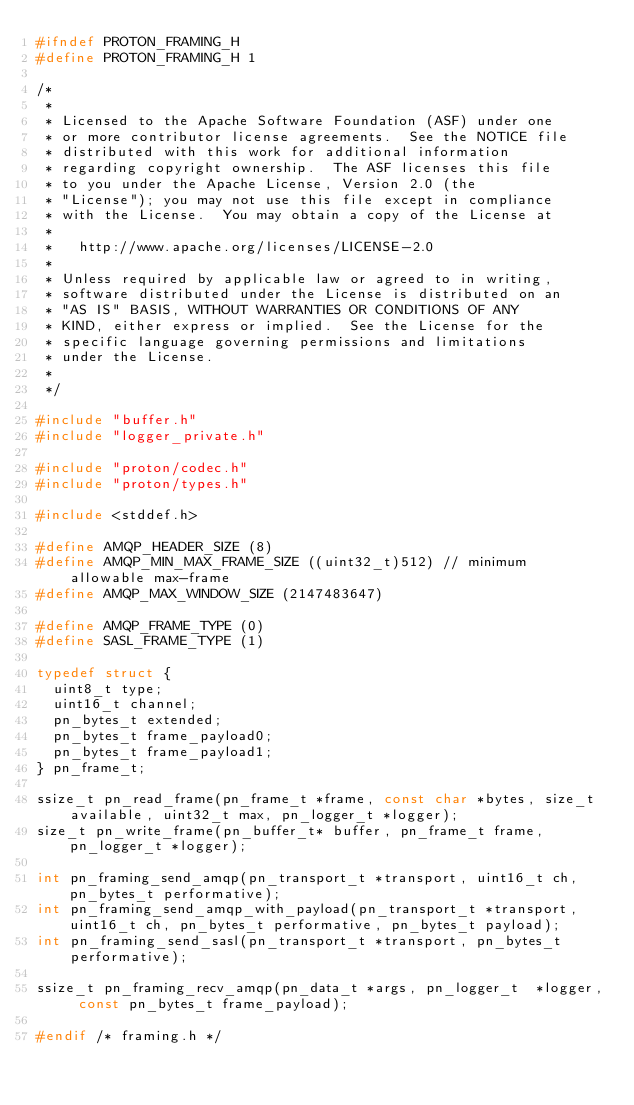Convert code to text. <code><loc_0><loc_0><loc_500><loc_500><_C_>#ifndef PROTON_FRAMING_H
#define PROTON_FRAMING_H 1

/*
 *
 * Licensed to the Apache Software Foundation (ASF) under one
 * or more contributor license agreements.  See the NOTICE file
 * distributed with this work for additional information
 * regarding copyright ownership.  The ASF licenses this file
 * to you under the Apache License, Version 2.0 (the
 * "License"); you may not use this file except in compliance
 * with the License.  You may obtain a copy of the License at
 *
 *   http://www.apache.org/licenses/LICENSE-2.0
 *
 * Unless required by applicable law or agreed to in writing,
 * software distributed under the License is distributed on an
 * "AS IS" BASIS, WITHOUT WARRANTIES OR CONDITIONS OF ANY
 * KIND, either express or implied.  See the License for the
 * specific language governing permissions and limitations
 * under the License.
 *
 */

#include "buffer.h"
#include "logger_private.h"

#include "proton/codec.h"
#include "proton/types.h"

#include <stddef.h>

#define AMQP_HEADER_SIZE (8)
#define AMQP_MIN_MAX_FRAME_SIZE ((uint32_t)512) // minimum allowable max-frame
#define AMQP_MAX_WINDOW_SIZE (2147483647)

#define AMQP_FRAME_TYPE (0)
#define SASL_FRAME_TYPE (1)

typedef struct {
  uint8_t type;
  uint16_t channel;
  pn_bytes_t extended;
  pn_bytes_t frame_payload0;
  pn_bytes_t frame_payload1;
} pn_frame_t;

ssize_t pn_read_frame(pn_frame_t *frame, const char *bytes, size_t available, uint32_t max, pn_logger_t *logger);
size_t pn_write_frame(pn_buffer_t* buffer, pn_frame_t frame, pn_logger_t *logger);

int pn_framing_send_amqp(pn_transport_t *transport, uint16_t ch, pn_bytes_t performative);
int pn_framing_send_amqp_with_payload(pn_transport_t *transport, uint16_t ch, pn_bytes_t performative, pn_bytes_t payload);
int pn_framing_send_sasl(pn_transport_t *transport, pn_bytes_t performative);

ssize_t pn_framing_recv_amqp(pn_data_t *args, pn_logger_t  *logger, const pn_bytes_t frame_payload);

#endif /* framing.h */
</code> 